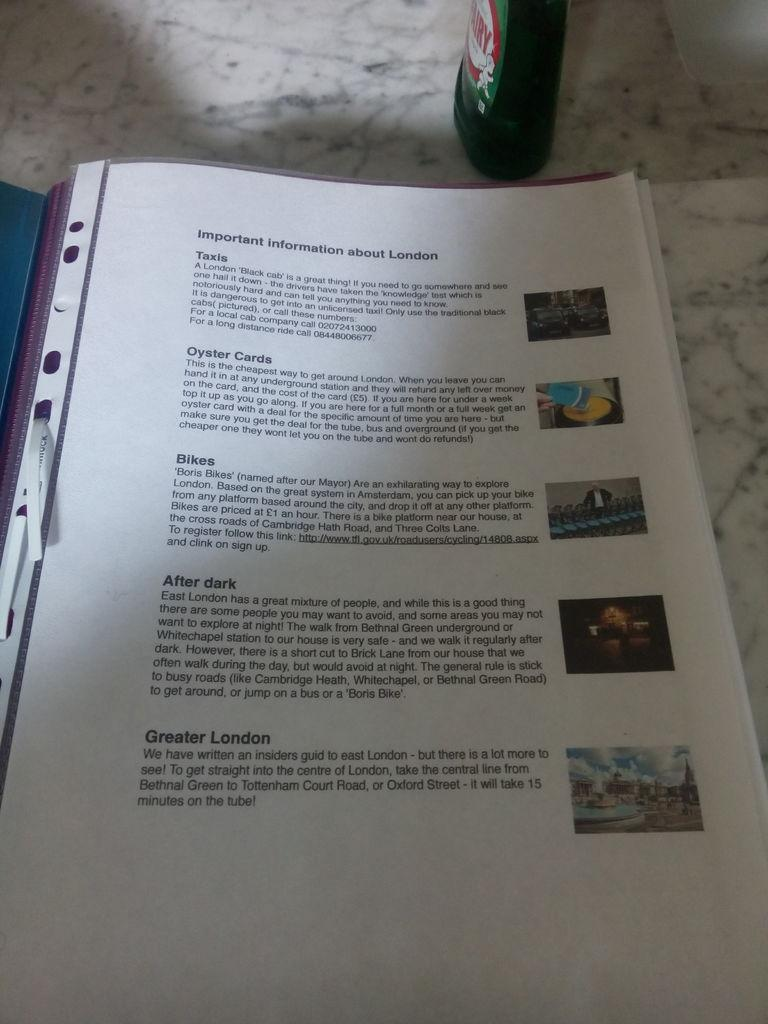<image>
Provide a brief description of the given image. A page contains important information about London, such as Taxis and Oyster Cards. 